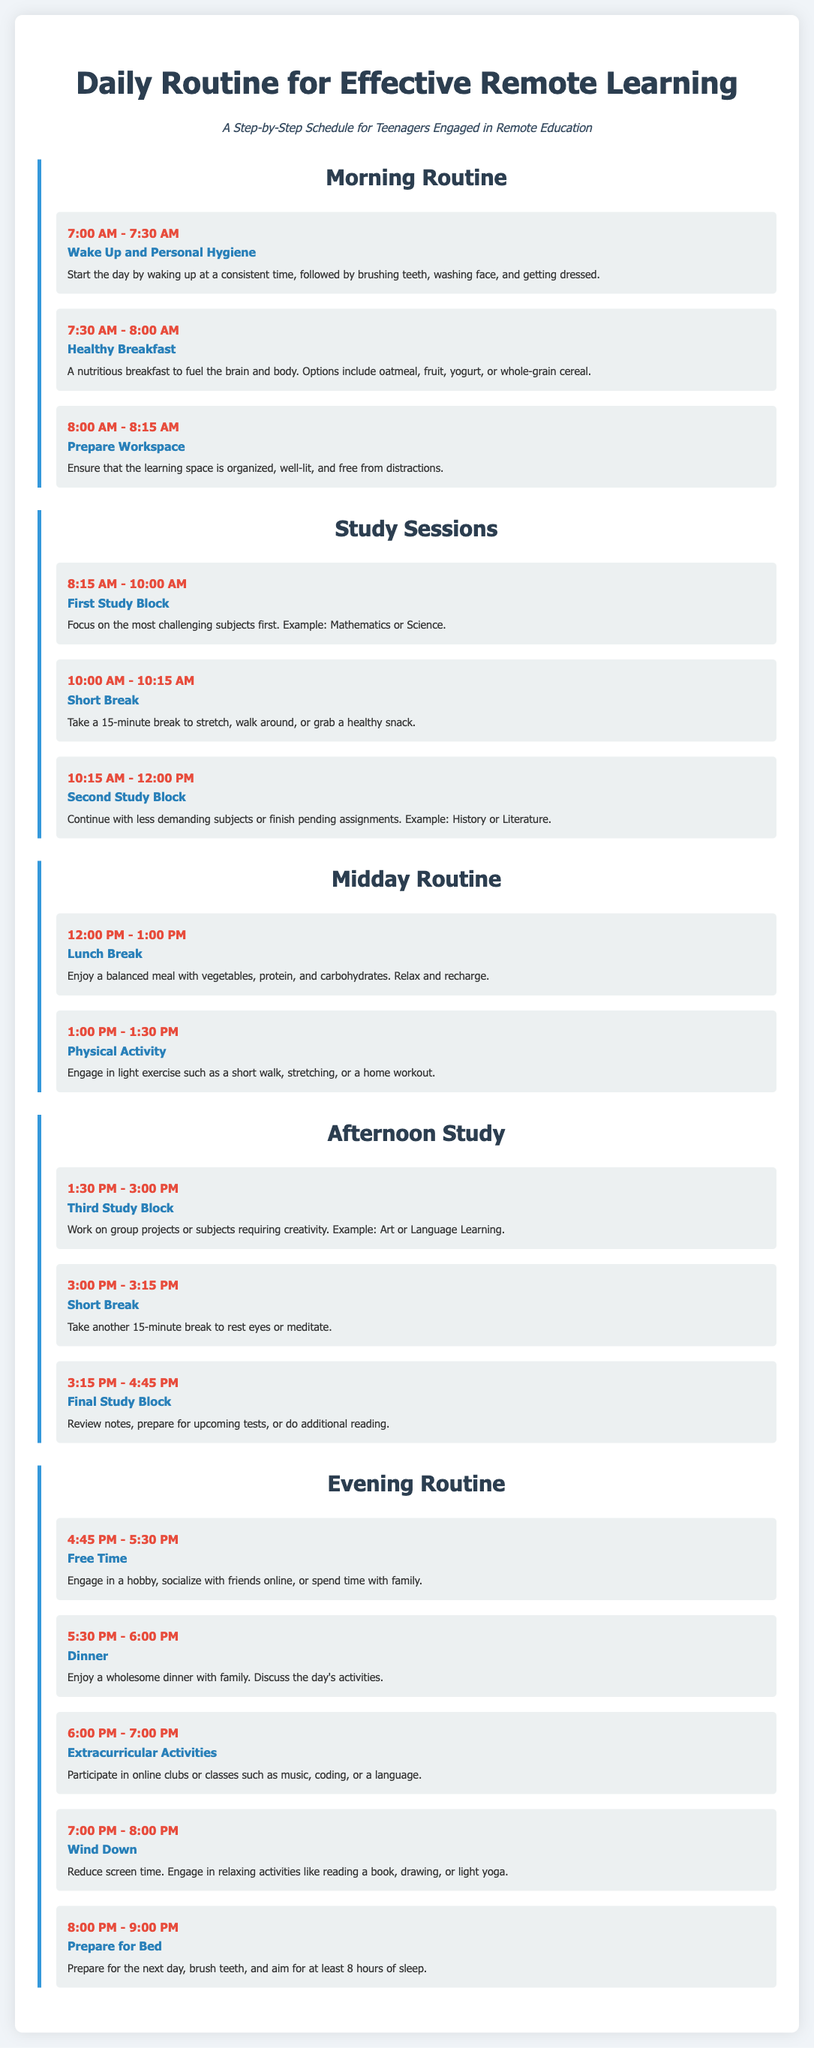What time does the first study block begin? The first study block begins at 8:15 AM as outlined in the study sessions section of the document.
Answer: 8:15 AM What activity is suggested at 4:45 PM? At 4:45 PM, the suggested activity is "Free Time" where students can engage in hobbies, socialize, or spend time with family.
Answer: Free Time How long is the lunch break? The lunch break lasts for 1 hour, from 12:00 PM to 1:00 PM as indicated in the midday routine section.
Answer: 1 hour What is the recommended time for preparing for bed? The recommended time for preparing for bed is from 8:00 PM to 9:00 PM according to the evening routine outlined in the document.
Answer: 8:00 PM - 9:00 PM What is the duration of each study block? Each study block, except for breaks, lasts for 1 hour and 45 minutes as denoted in the study sessions section.
Answer: 1 hour and 45 minutes What type of activities can be included in extracurricular time? The document suggests engaging in online clubs or classes such as music, coding, or a language during extracurricular activities.
Answer: music, coding, or a language Why is it important to prepare the workspace? It is important to prepare the workspace to ensure it is organized, well-lit, and free from distractions which aids effective studying.
Answer: Organized, well-lit, free from distractions What time is the dinner scheduled? Dinner is scheduled for 5:30 PM to 6:00 PM as indicated in the evening routine section.
Answer: 5:30 PM - 6:00 PM Which subjects should be focused on during the first study block? The first study block should focus on the most challenging subjects, specifically mentioned as Mathematics or Science.
Answer: Mathematics or Science 